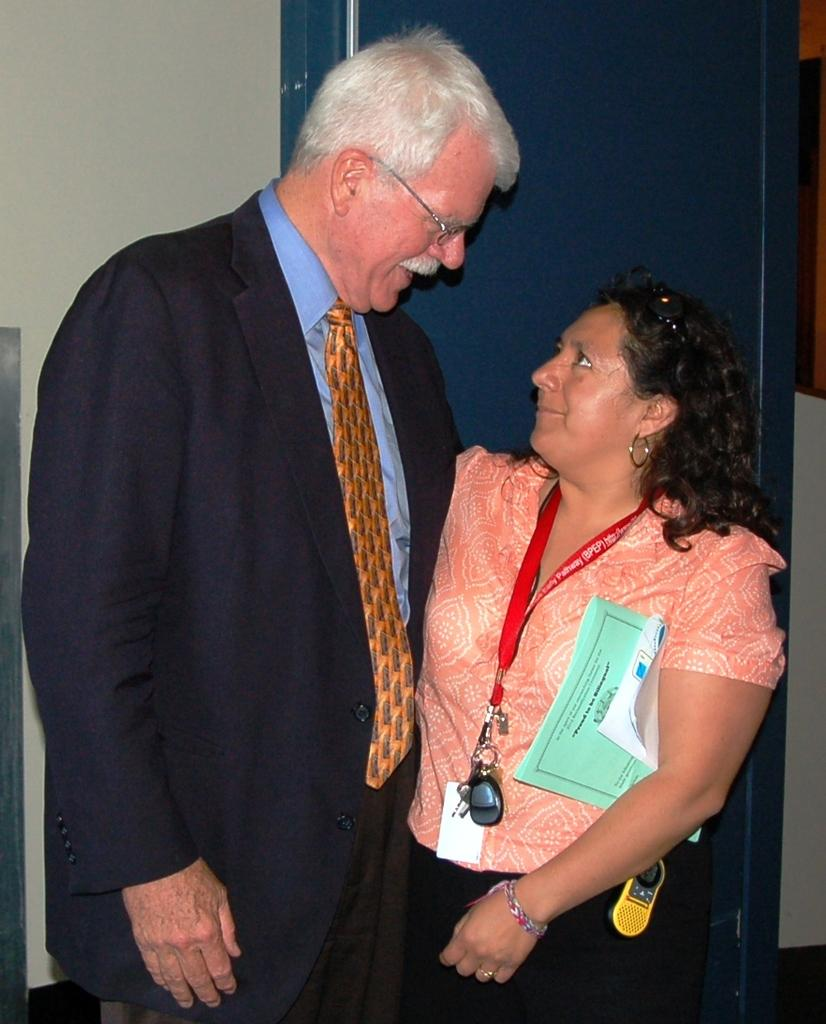How many people are in the image? There are two persons in the image. Can you describe the attire of one of the persons? One person is wearing spectacles, a coat, and a tie. What is the woman holding in the image? The woman is holding papers. What can be seen in the background of the image? There is a wall in the background of the image. What type of farming equipment can be seen in the image? There is no farming equipment present in the image. What position does the person holding papers have in the image? The image does not provide information about the person's position or role. 